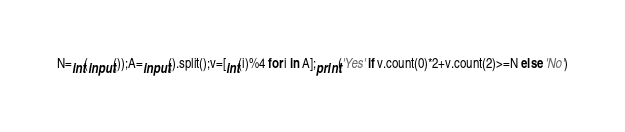Convert code to text. <code><loc_0><loc_0><loc_500><loc_500><_Python_>N=int(input());A=input().split();v=[int(i)%4 for i in A];print('Yes' if v.count(0)*2+v.count(2)>=N else 'No')</code> 